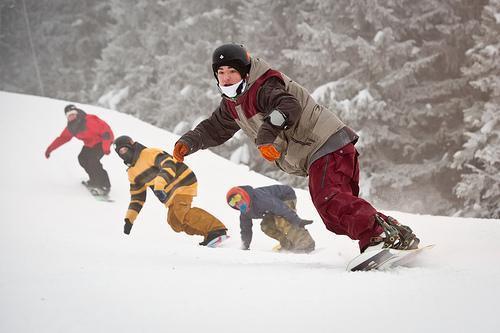How many people are in the photo?
Give a very brief answer. 4. 